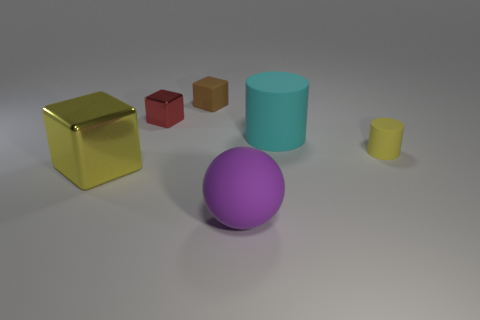Add 3 tiny purple metal blocks. How many objects exist? 9 Subtract all spheres. How many objects are left? 5 Subtract 0 cyan spheres. How many objects are left? 6 Subtract all tiny things. Subtract all cylinders. How many objects are left? 1 Add 1 rubber things. How many rubber things are left? 5 Add 2 yellow metal blocks. How many yellow metal blocks exist? 3 